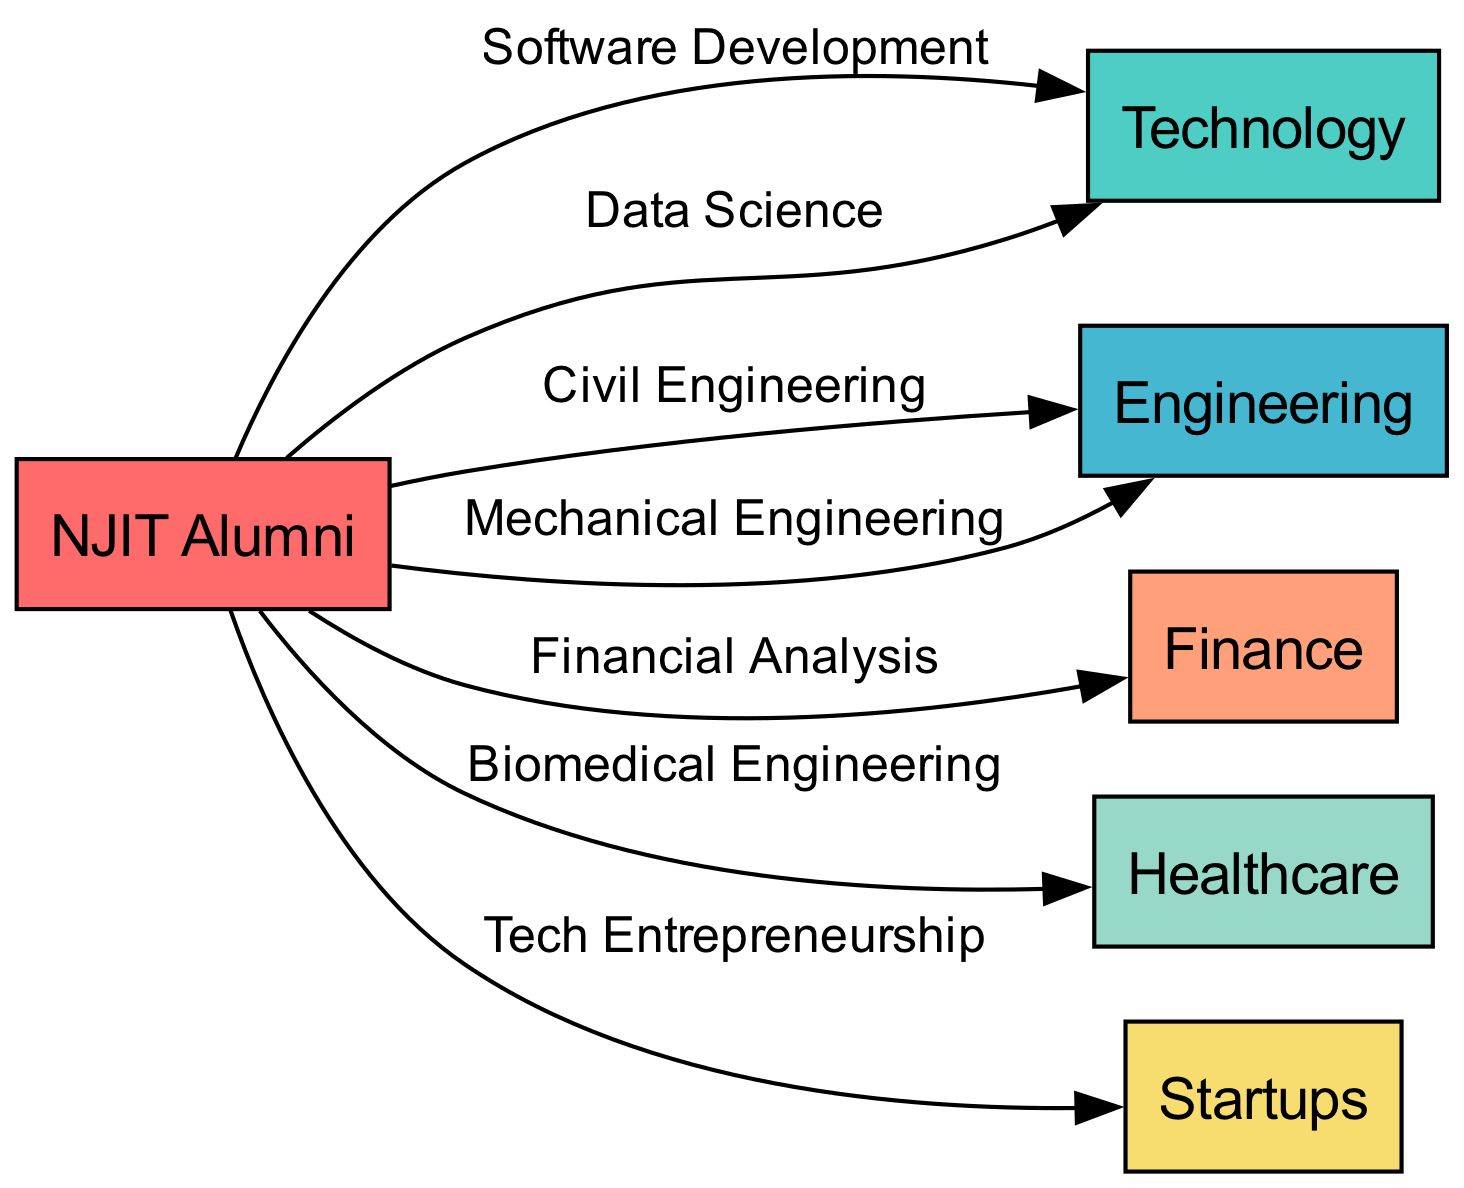What are the different career paths available for NJIT Alumni? The diagram shows several nodes related to career paths for NJIT Alumni: Technology, Engineering, Finance, Healthcare, and Startups. Thus, these paths are indicated as the main areas where alumni may pursue their careers.
Answer: Technology, Engineering, Finance, Healthcare, Startups How many industries are represented in the diagram? By counting the nodes connected to NJIT Alumni, which are Technology, Engineering, Finance, Healthcare, and Startups, we find a total of five distinct industries represented.
Answer: 5 Which career path is associated with Biomedical Engineering? Looking at the edges stemming from the NJIT Alumni node, we see that Biomedical Engineering is linked to the Healthcare node, indicating that this career path falls under the healthcare industry.
Answer: Healthcare What software development is categorized under? The edge from the NJIT Alumni node to the Tech node that cites 'Software Development' indicates that this career path is categorized under the Technology industry.
Answer: Technology Which career path leads to Tech Entrepreneurship? The diagram points from NJIT Alumni to Startups with 'Tech Entrepreneurship,' showing that this path is specifically directed towards the Startups industry.
Answer: Startups What kind of engineering is linked to Civil Engineering? The relationship from NJIT Alumni to the Engineering node, where 'Civil Engineering' is mentioned as a specific career path, indicates that Civil Engineering is associated with the Engineering industry.
Answer: Engineering How many edges connect NJIT Alumni to various career paths? By observing the connections (edges) extending from the NJIT Alumni node, we count a total of six edges: Software Development, Data Science, Civil Engineering, Mechanical Engineering, Financial Analysis, Biomedical Engineering, and Tech Entrepreneurship. Therefore, the total number of connections is six.
Answer: 6 Which finance career is mentioned in the diagram? The edge from NJIT Alumni to the Finance node identifies 'Financial Analysis,' indicating this specific career path within the finance industry.
Answer: Financial Analysis What does the relationship between NJIT Alumni and Startups signify? The edge labeled 'Tech Entrepreneurship' from NJIT Alumni to the Startups node signifies that this career path represents an affiliation between NJIT Alumni and the Startup industry, particularly in the tech sector.
Answer: Tech Entrepreneurship 